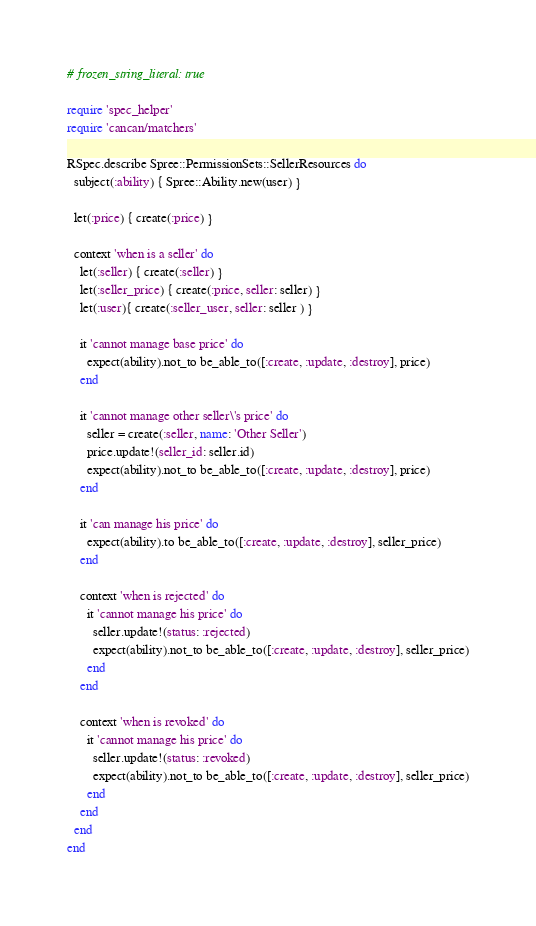Convert code to text. <code><loc_0><loc_0><loc_500><loc_500><_Ruby_># frozen_string_literal: true

require 'spec_helper'
require 'cancan/matchers'

RSpec.describe Spree::PermissionSets::SellerResources do
  subject(:ability) { Spree::Ability.new(user) }

  let(:price) { create(:price) }

  context 'when is a seller' do
    let(:seller) { create(:seller) }
    let(:seller_price) { create(:price, seller: seller) }
    let(:user){ create(:seller_user, seller: seller ) }

    it 'cannot manage base price' do
      expect(ability).not_to be_able_to([:create, :update, :destroy], price)
    end

    it 'cannot manage other seller\'s price' do
      seller = create(:seller, name: 'Other Seller')
      price.update!(seller_id: seller.id)
      expect(ability).not_to be_able_to([:create, :update, :destroy], price)
    end

    it 'can manage his price' do
      expect(ability).to be_able_to([:create, :update, :destroy], seller_price)
    end

    context 'when is rejected' do
      it 'cannot manage his price' do
        seller.update!(status: :rejected)
        expect(ability).not_to be_able_to([:create, :update, :destroy], seller_price)
      end
    end

    context 'when is revoked' do
      it 'cannot manage his price' do
        seller.update!(status: :revoked)
        expect(ability).not_to be_able_to([:create, :update, :destroy], seller_price)
      end
    end
  end
end
</code> 